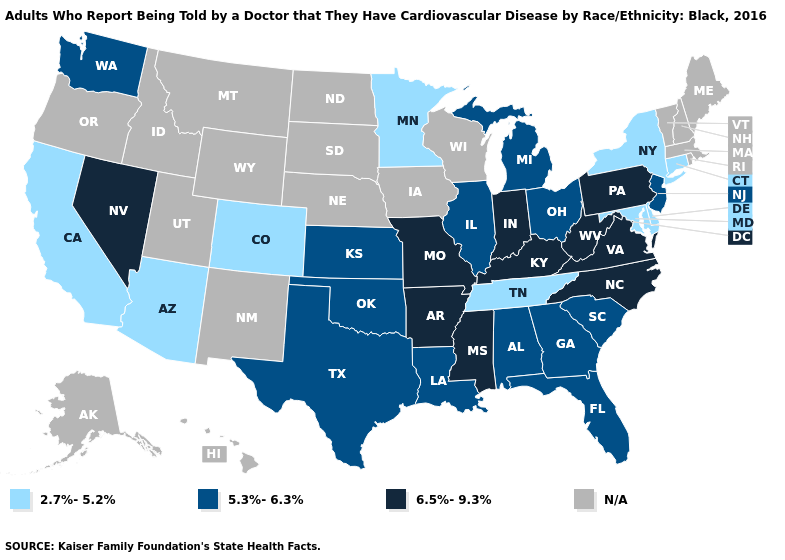What is the highest value in the USA?
Be succinct. 6.5%-9.3%. What is the lowest value in the Northeast?
Write a very short answer. 2.7%-5.2%. Among the states that border New Jersey , does Pennsylvania have the highest value?
Quick response, please. Yes. Name the states that have a value in the range 2.7%-5.2%?
Keep it brief. Arizona, California, Colorado, Connecticut, Delaware, Maryland, Minnesota, New York, Tennessee. Is the legend a continuous bar?
Keep it brief. No. How many symbols are there in the legend?
Give a very brief answer. 4. What is the value of California?
Concise answer only. 2.7%-5.2%. Which states hav the highest value in the MidWest?
Quick response, please. Indiana, Missouri. Does Texas have the highest value in the USA?
Write a very short answer. No. What is the lowest value in states that border Missouri?
Quick response, please. 2.7%-5.2%. What is the highest value in states that border Wisconsin?
Give a very brief answer. 5.3%-6.3%. Which states hav the highest value in the MidWest?
Give a very brief answer. Indiana, Missouri. Name the states that have a value in the range 6.5%-9.3%?
Keep it brief. Arkansas, Indiana, Kentucky, Mississippi, Missouri, Nevada, North Carolina, Pennsylvania, Virginia, West Virginia. 